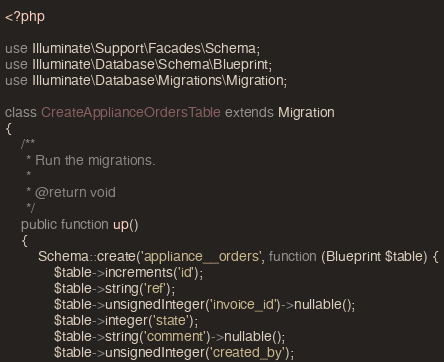<code> <loc_0><loc_0><loc_500><loc_500><_PHP_><?php

use Illuminate\Support\Facades\Schema;
use Illuminate\Database\Schema\Blueprint;
use Illuminate\Database\Migrations\Migration;

class CreateApplianceOrdersTable extends Migration
{
    /**
     * Run the migrations.
     *
     * @return void
     */
    public function up()
    {
        Schema::create('appliance__orders', function (Blueprint $table) {
            $table->increments('id');
            $table->string('ref');
            $table->unsignedInteger('invoice_id')->nullable();
            $table->integer('state');
            $table->string('comment')->nullable();
            $table->unsignedInteger('created_by');
</code> 